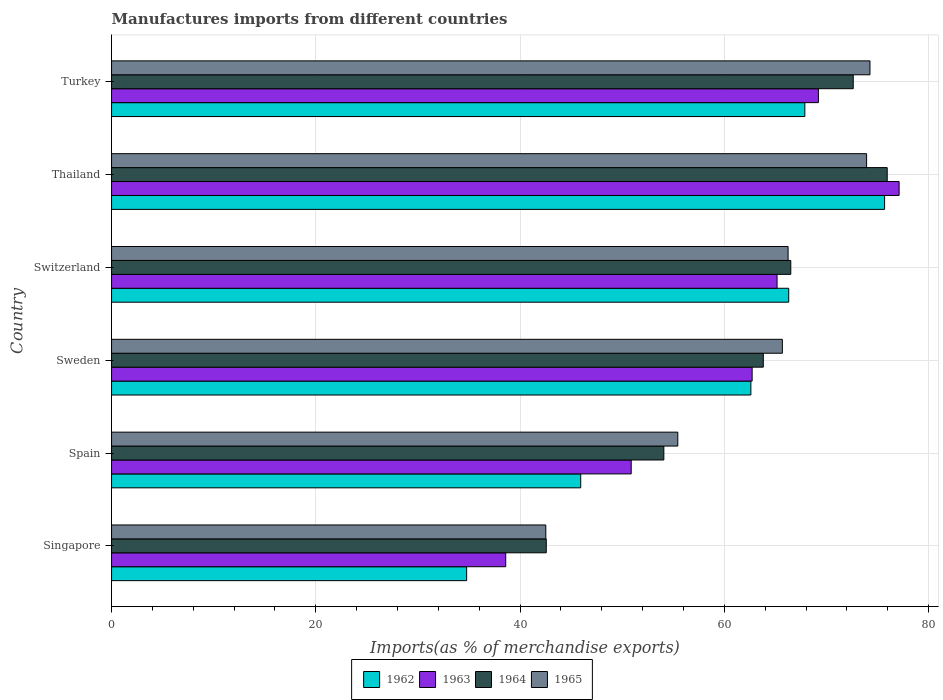How many different coloured bars are there?
Your answer should be compact. 4. Are the number of bars per tick equal to the number of legend labels?
Make the answer very short. Yes. Are the number of bars on each tick of the Y-axis equal?
Your answer should be very brief. Yes. How many bars are there on the 2nd tick from the top?
Your response must be concise. 4. How many bars are there on the 4th tick from the bottom?
Offer a very short reply. 4. What is the label of the 5th group of bars from the top?
Make the answer very short. Spain. In how many cases, is the number of bars for a given country not equal to the number of legend labels?
Ensure brevity in your answer.  0. What is the percentage of imports to different countries in 1965 in Thailand?
Your response must be concise. 73.93. Across all countries, what is the maximum percentage of imports to different countries in 1965?
Keep it short and to the point. 74.26. Across all countries, what is the minimum percentage of imports to different countries in 1964?
Ensure brevity in your answer.  42.56. In which country was the percentage of imports to different countries in 1965 maximum?
Offer a very short reply. Turkey. In which country was the percentage of imports to different countries in 1964 minimum?
Give a very brief answer. Singapore. What is the total percentage of imports to different countries in 1964 in the graph?
Give a very brief answer. 375.54. What is the difference between the percentage of imports to different countries in 1965 in Singapore and that in Switzerland?
Offer a very short reply. -23.72. What is the difference between the percentage of imports to different countries in 1965 in Turkey and the percentage of imports to different countries in 1964 in Singapore?
Your answer should be very brief. 31.7. What is the average percentage of imports to different countries in 1965 per country?
Provide a short and direct response. 63.01. What is the difference between the percentage of imports to different countries in 1964 and percentage of imports to different countries in 1963 in Sweden?
Offer a terse response. 1.09. What is the ratio of the percentage of imports to different countries in 1963 in Sweden to that in Turkey?
Offer a terse response. 0.91. Is the percentage of imports to different countries in 1964 in Sweden less than that in Switzerland?
Your answer should be compact. Yes. Is the difference between the percentage of imports to different countries in 1964 in Sweden and Turkey greater than the difference between the percentage of imports to different countries in 1963 in Sweden and Turkey?
Give a very brief answer. No. What is the difference between the highest and the second highest percentage of imports to different countries in 1963?
Offer a very short reply. 7.9. What is the difference between the highest and the lowest percentage of imports to different countries in 1963?
Keep it short and to the point. 38.52. In how many countries, is the percentage of imports to different countries in 1964 greater than the average percentage of imports to different countries in 1964 taken over all countries?
Offer a very short reply. 4. What does the 3rd bar from the top in Switzerland represents?
Your answer should be compact. 1963. Is it the case that in every country, the sum of the percentage of imports to different countries in 1964 and percentage of imports to different countries in 1963 is greater than the percentage of imports to different countries in 1965?
Provide a short and direct response. Yes. How many countries are there in the graph?
Your response must be concise. 6. Are the values on the major ticks of X-axis written in scientific E-notation?
Ensure brevity in your answer.  No. Does the graph contain any zero values?
Your answer should be compact. No. How many legend labels are there?
Offer a terse response. 4. How are the legend labels stacked?
Provide a short and direct response. Horizontal. What is the title of the graph?
Provide a short and direct response. Manufactures imports from different countries. Does "1968" appear as one of the legend labels in the graph?
Your answer should be compact. No. What is the label or title of the X-axis?
Ensure brevity in your answer.  Imports(as % of merchandise exports). What is the label or title of the Y-axis?
Your answer should be very brief. Country. What is the Imports(as % of merchandise exports) in 1962 in Singapore?
Your response must be concise. 34.77. What is the Imports(as % of merchandise exports) of 1963 in Singapore?
Keep it short and to the point. 38.6. What is the Imports(as % of merchandise exports) of 1964 in Singapore?
Your answer should be compact. 42.56. What is the Imports(as % of merchandise exports) in 1965 in Singapore?
Make the answer very short. 42.52. What is the Imports(as % of merchandise exports) in 1962 in Spain?
Offer a very short reply. 45.94. What is the Imports(as % of merchandise exports) of 1963 in Spain?
Offer a terse response. 50.88. What is the Imports(as % of merchandise exports) in 1964 in Spain?
Your answer should be compact. 54.08. What is the Imports(as % of merchandise exports) of 1965 in Spain?
Your answer should be compact. 55.44. What is the Imports(as % of merchandise exports) of 1962 in Sweden?
Your answer should be compact. 62.6. What is the Imports(as % of merchandise exports) in 1963 in Sweden?
Your response must be concise. 62.72. What is the Imports(as % of merchandise exports) in 1964 in Sweden?
Your response must be concise. 63.82. What is the Imports(as % of merchandise exports) of 1965 in Sweden?
Make the answer very short. 65.68. What is the Imports(as % of merchandise exports) of 1962 in Switzerland?
Your answer should be very brief. 66.31. What is the Imports(as % of merchandise exports) in 1963 in Switzerland?
Your answer should be compact. 65.16. What is the Imports(as % of merchandise exports) in 1964 in Switzerland?
Give a very brief answer. 66.51. What is the Imports(as % of merchandise exports) in 1965 in Switzerland?
Ensure brevity in your answer.  66.24. What is the Imports(as % of merchandise exports) of 1962 in Thailand?
Give a very brief answer. 75.69. What is the Imports(as % of merchandise exports) of 1963 in Thailand?
Your answer should be very brief. 77.12. What is the Imports(as % of merchandise exports) of 1964 in Thailand?
Give a very brief answer. 75.95. What is the Imports(as % of merchandise exports) in 1965 in Thailand?
Provide a short and direct response. 73.93. What is the Imports(as % of merchandise exports) in 1962 in Turkey?
Your response must be concise. 67.88. What is the Imports(as % of merchandise exports) in 1963 in Turkey?
Provide a short and direct response. 69.21. What is the Imports(as % of merchandise exports) of 1964 in Turkey?
Offer a terse response. 72.62. What is the Imports(as % of merchandise exports) in 1965 in Turkey?
Offer a terse response. 74.26. Across all countries, what is the maximum Imports(as % of merchandise exports) in 1962?
Provide a short and direct response. 75.69. Across all countries, what is the maximum Imports(as % of merchandise exports) in 1963?
Make the answer very short. 77.12. Across all countries, what is the maximum Imports(as % of merchandise exports) in 1964?
Give a very brief answer. 75.95. Across all countries, what is the maximum Imports(as % of merchandise exports) of 1965?
Provide a succinct answer. 74.26. Across all countries, what is the minimum Imports(as % of merchandise exports) of 1962?
Ensure brevity in your answer.  34.77. Across all countries, what is the minimum Imports(as % of merchandise exports) of 1963?
Provide a short and direct response. 38.6. Across all countries, what is the minimum Imports(as % of merchandise exports) of 1964?
Your answer should be compact. 42.56. Across all countries, what is the minimum Imports(as % of merchandise exports) in 1965?
Keep it short and to the point. 42.52. What is the total Imports(as % of merchandise exports) of 1962 in the graph?
Provide a succinct answer. 353.19. What is the total Imports(as % of merchandise exports) of 1963 in the graph?
Your response must be concise. 363.69. What is the total Imports(as % of merchandise exports) of 1964 in the graph?
Your answer should be compact. 375.54. What is the total Imports(as % of merchandise exports) of 1965 in the graph?
Give a very brief answer. 378.08. What is the difference between the Imports(as % of merchandise exports) of 1962 in Singapore and that in Spain?
Provide a succinct answer. -11.17. What is the difference between the Imports(as % of merchandise exports) in 1963 in Singapore and that in Spain?
Give a very brief answer. -12.29. What is the difference between the Imports(as % of merchandise exports) of 1964 in Singapore and that in Spain?
Your answer should be compact. -11.51. What is the difference between the Imports(as % of merchandise exports) in 1965 in Singapore and that in Spain?
Your answer should be compact. -12.92. What is the difference between the Imports(as % of merchandise exports) in 1962 in Singapore and that in Sweden?
Give a very brief answer. -27.83. What is the difference between the Imports(as % of merchandise exports) in 1963 in Singapore and that in Sweden?
Provide a short and direct response. -24.13. What is the difference between the Imports(as % of merchandise exports) in 1964 in Singapore and that in Sweden?
Ensure brevity in your answer.  -21.25. What is the difference between the Imports(as % of merchandise exports) in 1965 in Singapore and that in Sweden?
Offer a very short reply. -23.16. What is the difference between the Imports(as % of merchandise exports) in 1962 in Singapore and that in Switzerland?
Your response must be concise. -31.54. What is the difference between the Imports(as % of merchandise exports) in 1963 in Singapore and that in Switzerland?
Keep it short and to the point. -26.57. What is the difference between the Imports(as % of merchandise exports) of 1964 in Singapore and that in Switzerland?
Your response must be concise. -23.94. What is the difference between the Imports(as % of merchandise exports) of 1965 in Singapore and that in Switzerland?
Keep it short and to the point. -23.72. What is the difference between the Imports(as % of merchandise exports) in 1962 in Singapore and that in Thailand?
Ensure brevity in your answer.  -40.92. What is the difference between the Imports(as % of merchandise exports) of 1963 in Singapore and that in Thailand?
Offer a terse response. -38.52. What is the difference between the Imports(as % of merchandise exports) of 1964 in Singapore and that in Thailand?
Provide a succinct answer. -33.38. What is the difference between the Imports(as % of merchandise exports) of 1965 in Singapore and that in Thailand?
Your answer should be compact. -31.41. What is the difference between the Imports(as % of merchandise exports) in 1962 in Singapore and that in Turkey?
Keep it short and to the point. -33.11. What is the difference between the Imports(as % of merchandise exports) in 1963 in Singapore and that in Turkey?
Provide a short and direct response. -30.62. What is the difference between the Imports(as % of merchandise exports) in 1964 in Singapore and that in Turkey?
Ensure brevity in your answer.  -30.06. What is the difference between the Imports(as % of merchandise exports) of 1965 in Singapore and that in Turkey?
Make the answer very short. -31.74. What is the difference between the Imports(as % of merchandise exports) of 1962 in Spain and that in Sweden?
Provide a short and direct response. -16.66. What is the difference between the Imports(as % of merchandise exports) in 1963 in Spain and that in Sweden?
Your response must be concise. -11.84. What is the difference between the Imports(as % of merchandise exports) of 1964 in Spain and that in Sweden?
Your response must be concise. -9.74. What is the difference between the Imports(as % of merchandise exports) in 1965 in Spain and that in Sweden?
Make the answer very short. -10.24. What is the difference between the Imports(as % of merchandise exports) of 1962 in Spain and that in Switzerland?
Your answer should be very brief. -20.37. What is the difference between the Imports(as % of merchandise exports) in 1963 in Spain and that in Switzerland?
Your answer should be compact. -14.28. What is the difference between the Imports(as % of merchandise exports) of 1964 in Spain and that in Switzerland?
Offer a very short reply. -12.43. What is the difference between the Imports(as % of merchandise exports) in 1965 in Spain and that in Switzerland?
Offer a terse response. -10.8. What is the difference between the Imports(as % of merchandise exports) of 1962 in Spain and that in Thailand?
Your answer should be very brief. -29.75. What is the difference between the Imports(as % of merchandise exports) in 1963 in Spain and that in Thailand?
Offer a very short reply. -26.23. What is the difference between the Imports(as % of merchandise exports) in 1964 in Spain and that in Thailand?
Your response must be concise. -21.87. What is the difference between the Imports(as % of merchandise exports) of 1965 in Spain and that in Thailand?
Ensure brevity in your answer.  -18.49. What is the difference between the Imports(as % of merchandise exports) in 1962 in Spain and that in Turkey?
Give a very brief answer. -21.94. What is the difference between the Imports(as % of merchandise exports) in 1963 in Spain and that in Turkey?
Your response must be concise. -18.33. What is the difference between the Imports(as % of merchandise exports) of 1964 in Spain and that in Turkey?
Offer a terse response. -18.54. What is the difference between the Imports(as % of merchandise exports) in 1965 in Spain and that in Turkey?
Make the answer very short. -18.82. What is the difference between the Imports(as % of merchandise exports) of 1962 in Sweden and that in Switzerland?
Make the answer very short. -3.71. What is the difference between the Imports(as % of merchandise exports) in 1963 in Sweden and that in Switzerland?
Your response must be concise. -2.44. What is the difference between the Imports(as % of merchandise exports) in 1964 in Sweden and that in Switzerland?
Provide a succinct answer. -2.69. What is the difference between the Imports(as % of merchandise exports) of 1965 in Sweden and that in Switzerland?
Keep it short and to the point. -0.56. What is the difference between the Imports(as % of merchandise exports) in 1962 in Sweden and that in Thailand?
Your answer should be very brief. -13.09. What is the difference between the Imports(as % of merchandise exports) in 1963 in Sweden and that in Thailand?
Your answer should be very brief. -14.39. What is the difference between the Imports(as % of merchandise exports) of 1964 in Sweden and that in Thailand?
Your answer should be very brief. -12.13. What is the difference between the Imports(as % of merchandise exports) of 1965 in Sweden and that in Thailand?
Offer a very short reply. -8.25. What is the difference between the Imports(as % of merchandise exports) in 1962 in Sweden and that in Turkey?
Make the answer very short. -5.28. What is the difference between the Imports(as % of merchandise exports) in 1963 in Sweden and that in Turkey?
Offer a very short reply. -6.49. What is the difference between the Imports(as % of merchandise exports) of 1964 in Sweden and that in Turkey?
Make the answer very short. -8.81. What is the difference between the Imports(as % of merchandise exports) in 1965 in Sweden and that in Turkey?
Your response must be concise. -8.58. What is the difference between the Imports(as % of merchandise exports) in 1962 in Switzerland and that in Thailand?
Your response must be concise. -9.39. What is the difference between the Imports(as % of merchandise exports) in 1963 in Switzerland and that in Thailand?
Offer a terse response. -11.95. What is the difference between the Imports(as % of merchandise exports) of 1964 in Switzerland and that in Thailand?
Your answer should be compact. -9.44. What is the difference between the Imports(as % of merchandise exports) in 1965 in Switzerland and that in Thailand?
Provide a succinct answer. -7.69. What is the difference between the Imports(as % of merchandise exports) in 1962 in Switzerland and that in Turkey?
Your answer should be very brief. -1.58. What is the difference between the Imports(as % of merchandise exports) of 1963 in Switzerland and that in Turkey?
Your response must be concise. -4.05. What is the difference between the Imports(as % of merchandise exports) in 1964 in Switzerland and that in Turkey?
Your answer should be very brief. -6.12. What is the difference between the Imports(as % of merchandise exports) in 1965 in Switzerland and that in Turkey?
Your answer should be very brief. -8.02. What is the difference between the Imports(as % of merchandise exports) in 1962 in Thailand and that in Turkey?
Provide a succinct answer. 7.81. What is the difference between the Imports(as % of merchandise exports) of 1963 in Thailand and that in Turkey?
Your answer should be compact. 7.9. What is the difference between the Imports(as % of merchandise exports) in 1964 in Thailand and that in Turkey?
Give a very brief answer. 3.33. What is the difference between the Imports(as % of merchandise exports) of 1965 in Thailand and that in Turkey?
Your response must be concise. -0.33. What is the difference between the Imports(as % of merchandise exports) in 1962 in Singapore and the Imports(as % of merchandise exports) in 1963 in Spain?
Your response must be concise. -16.11. What is the difference between the Imports(as % of merchandise exports) of 1962 in Singapore and the Imports(as % of merchandise exports) of 1964 in Spain?
Offer a very short reply. -19.31. What is the difference between the Imports(as % of merchandise exports) of 1962 in Singapore and the Imports(as % of merchandise exports) of 1965 in Spain?
Your response must be concise. -20.68. What is the difference between the Imports(as % of merchandise exports) of 1963 in Singapore and the Imports(as % of merchandise exports) of 1964 in Spain?
Your response must be concise. -15.48. What is the difference between the Imports(as % of merchandise exports) of 1963 in Singapore and the Imports(as % of merchandise exports) of 1965 in Spain?
Ensure brevity in your answer.  -16.85. What is the difference between the Imports(as % of merchandise exports) in 1964 in Singapore and the Imports(as % of merchandise exports) in 1965 in Spain?
Provide a succinct answer. -12.88. What is the difference between the Imports(as % of merchandise exports) in 1962 in Singapore and the Imports(as % of merchandise exports) in 1963 in Sweden?
Give a very brief answer. -27.95. What is the difference between the Imports(as % of merchandise exports) in 1962 in Singapore and the Imports(as % of merchandise exports) in 1964 in Sweden?
Provide a succinct answer. -29.05. What is the difference between the Imports(as % of merchandise exports) in 1962 in Singapore and the Imports(as % of merchandise exports) in 1965 in Sweden?
Provide a succinct answer. -30.91. What is the difference between the Imports(as % of merchandise exports) in 1963 in Singapore and the Imports(as % of merchandise exports) in 1964 in Sweden?
Offer a terse response. -25.22. What is the difference between the Imports(as % of merchandise exports) in 1963 in Singapore and the Imports(as % of merchandise exports) in 1965 in Sweden?
Offer a very short reply. -27.09. What is the difference between the Imports(as % of merchandise exports) of 1964 in Singapore and the Imports(as % of merchandise exports) of 1965 in Sweden?
Your response must be concise. -23.12. What is the difference between the Imports(as % of merchandise exports) in 1962 in Singapore and the Imports(as % of merchandise exports) in 1963 in Switzerland?
Make the answer very short. -30.4. What is the difference between the Imports(as % of merchandise exports) in 1962 in Singapore and the Imports(as % of merchandise exports) in 1964 in Switzerland?
Make the answer very short. -31.74. What is the difference between the Imports(as % of merchandise exports) in 1962 in Singapore and the Imports(as % of merchandise exports) in 1965 in Switzerland?
Give a very brief answer. -31.48. What is the difference between the Imports(as % of merchandise exports) in 1963 in Singapore and the Imports(as % of merchandise exports) in 1964 in Switzerland?
Your answer should be compact. -27.91. What is the difference between the Imports(as % of merchandise exports) of 1963 in Singapore and the Imports(as % of merchandise exports) of 1965 in Switzerland?
Offer a very short reply. -27.65. What is the difference between the Imports(as % of merchandise exports) of 1964 in Singapore and the Imports(as % of merchandise exports) of 1965 in Switzerland?
Provide a short and direct response. -23.68. What is the difference between the Imports(as % of merchandise exports) of 1962 in Singapore and the Imports(as % of merchandise exports) of 1963 in Thailand?
Your answer should be very brief. -42.35. What is the difference between the Imports(as % of merchandise exports) in 1962 in Singapore and the Imports(as % of merchandise exports) in 1964 in Thailand?
Your answer should be very brief. -41.18. What is the difference between the Imports(as % of merchandise exports) of 1962 in Singapore and the Imports(as % of merchandise exports) of 1965 in Thailand?
Make the answer very short. -39.16. What is the difference between the Imports(as % of merchandise exports) of 1963 in Singapore and the Imports(as % of merchandise exports) of 1964 in Thailand?
Your response must be concise. -37.35. What is the difference between the Imports(as % of merchandise exports) of 1963 in Singapore and the Imports(as % of merchandise exports) of 1965 in Thailand?
Offer a very short reply. -35.34. What is the difference between the Imports(as % of merchandise exports) in 1964 in Singapore and the Imports(as % of merchandise exports) in 1965 in Thailand?
Make the answer very short. -31.37. What is the difference between the Imports(as % of merchandise exports) of 1962 in Singapore and the Imports(as % of merchandise exports) of 1963 in Turkey?
Your response must be concise. -34.44. What is the difference between the Imports(as % of merchandise exports) of 1962 in Singapore and the Imports(as % of merchandise exports) of 1964 in Turkey?
Offer a very short reply. -37.85. What is the difference between the Imports(as % of merchandise exports) of 1962 in Singapore and the Imports(as % of merchandise exports) of 1965 in Turkey?
Your response must be concise. -39.49. What is the difference between the Imports(as % of merchandise exports) in 1963 in Singapore and the Imports(as % of merchandise exports) in 1964 in Turkey?
Offer a very short reply. -34.03. What is the difference between the Imports(as % of merchandise exports) in 1963 in Singapore and the Imports(as % of merchandise exports) in 1965 in Turkey?
Make the answer very short. -35.67. What is the difference between the Imports(as % of merchandise exports) in 1964 in Singapore and the Imports(as % of merchandise exports) in 1965 in Turkey?
Provide a short and direct response. -31.7. What is the difference between the Imports(as % of merchandise exports) in 1962 in Spain and the Imports(as % of merchandise exports) in 1963 in Sweden?
Offer a very short reply. -16.78. What is the difference between the Imports(as % of merchandise exports) of 1962 in Spain and the Imports(as % of merchandise exports) of 1964 in Sweden?
Give a very brief answer. -17.88. What is the difference between the Imports(as % of merchandise exports) of 1962 in Spain and the Imports(as % of merchandise exports) of 1965 in Sweden?
Make the answer very short. -19.74. What is the difference between the Imports(as % of merchandise exports) in 1963 in Spain and the Imports(as % of merchandise exports) in 1964 in Sweden?
Give a very brief answer. -12.94. What is the difference between the Imports(as % of merchandise exports) in 1963 in Spain and the Imports(as % of merchandise exports) in 1965 in Sweden?
Make the answer very short. -14.8. What is the difference between the Imports(as % of merchandise exports) in 1964 in Spain and the Imports(as % of merchandise exports) in 1965 in Sweden?
Your answer should be compact. -11.6. What is the difference between the Imports(as % of merchandise exports) of 1962 in Spain and the Imports(as % of merchandise exports) of 1963 in Switzerland?
Make the answer very short. -19.23. What is the difference between the Imports(as % of merchandise exports) of 1962 in Spain and the Imports(as % of merchandise exports) of 1964 in Switzerland?
Make the answer very short. -20.57. What is the difference between the Imports(as % of merchandise exports) in 1962 in Spain and the Imports(as % of merchandise exports) in 1965 in Switzerland?
Offer a terse response. -20.31. What is the difference between the Imports(as % of merchandise exports) in 1963 in Spain and the Imports(as % of merchandise exports) in 1964 in Switzerland?
Offer a terse response. -15.63. What is the difference between the Imports(as % of merchandise exports) in 1963 in Spain and the Imports(as % of merchandise exports) in 1965 in Switzerland?
Keep it short and to the point. -15.36. What is the difference between the Imports(as % of merchandise exports) in 1964 in Spain and the Imports(as % of merchandise exports) in 1965 in Switzerland?
Offer a very short reply. -12.17. What is the difference between the Imports(as % of merchandise exports) in 1962 in Spain and the Imports(as % of merchandise exports) in 1963 in Thailand?
Make the answer very short. -31.18. What is the difference between the Imports(as % of merchandise exports) in 1962 in Spain and the Imports(as % of merchandise exports) in 1964 in Thailand?
Ensure brevity in your answer.  -30.01. What is the difference between the Imports(as % of merchandise exports) of 1962 in Spain and the Imports(as % of merchandise exports) of 1965 in Thailand?
Your response must be concise. -27.99. What is the difference between the Imports(as % of merchandise exports) in 1963 in Spain and the Imports(as % of merchandise exports) in 1964 in Thailand?
Offer a terse response. -25.07. What is the difference between the Imports(as % of merchandise exports) of 1963 in Spain and the Imports(as % of merchandise exports) of 1965 in Thailand?
Offer a very short reply. -23.05. What is the difference between the Imports(as % of merchandise exports) in 1964 in Spain and the Imports(as % of merchandise exports) in 1965 in Thailand?
Offer a terse response. -19.85. What is the difference between the Imports(as % of merchandise exports) of 1962 in Spain and the Imports(as % of merchandise exports) of 1963 in Turkey?
Provide a succinct answer. -23.27. What is the difference between the Imports(as % of merchandise exports) in 1962 in Spain and the Imports(as % of merchandise exports) in 1964 in Turkey?
Give a very brief answer. -26.68. What is the difference between the Imports(as % of merchandise exports) of 1962 in Spain and the Imports(as % of merchandise exports) of 1965 in Turkey?
Keep it short and to the point. -28.32. What is the difference between the Imports(as % of merchandise exports) of 1963 in Spain and the Imports(as % of merchandise exports) of 1964 in Turkey?
Your response must be concise. -21.74. What is the difference between the Imports(as % of merchandise exports) in 1963 in Spain and the Imports(as % of merchandise exports) in 1965 in Turkey?
Provide a short and direct response. -23.38. What is the difference between the Imports(as % of merchandise exports) of 1964 in Spain and the Imports(as % of merchandise exports) of 1965 in Turkey?
Make the answer very short. -20.18. What is the difference between the Imports(as % of merchandise exports) of 1962 in Sweden and the Imports(as % of merchandise exports) of 1963 in Switzerland?
Offer a very short reply. -2.57. What is the difference between the Imports(as % of merchandise exports) of 1962 in Sweden and the Imports(as % of merchandise exports) of 1964 in Switzerland?
Keep it short and to the point. -3.91. What is the difference between the Imports(as % of merchandise exports) of 1962 in Sweden and the Imports(as % of merchandise exports) of 1965 in Switzerland?
Give a very brief answer. -3.65. What is the difference between the Imports(as % of merchandise exports) in 1963 in Sweden and the Imports(as % of merchandise exports) in 1964 in Switzerland?
Offer a terse response. -3.78. What is the difference between the Imports(as % of merchandise exports) of 1963 in Sweden and the Imports(as % of merchandise exports) of 1965 in Switzerland?
Your answer should be very brief. -3.52. What is the difference between the Imports(as % of merchandise exports) in 1964 in Sweden and the Imports(as % of merchandise exports) in 1965 in Switzerland?
Your answer should be very brief. -2.43. What is the difference between the Imports(as % of merchandise exports) in 1962 in Sweden and the Imports(as % of merchandise exports) in 1963 in Thailand?
Offer a very short reply. -14.52. What is the difference between the Imports(as % of merchandise exports) of 1962 in Sweden and the Imports(as % of merchandise exports) of 1964 in Thailand?
Give a very brief answer. -13.35. What is the difference between the Imports(as % of merchandise exports) of 1962 in Sweden and the Imports(as % of merchandise exports) of 1965 in Thailand?
Your response must be concise. -11.33. What is the difference between the Imports(as % of merchandise exports) in 1963 in Sweden and the Imports(as % of merchandise exports) in 1964 in Thailand?
Make the answer very short. -13.23. What is the difference between the Imports(as % of merchandise exports) in 1963 in Sweden and the Imports(as % of merchandise exports) in 1965 in Thailand?
Give a very brief answer. -11.21. What is the difference between the Imports(as % of merchandise exports) of 1964 in Sweden and the Imports(as % of merchandise exports) of 1965 in Thailand?
Offer a very short reply. -10.11. What is the difference between the Imports(as % of merchandise exports) of 1962 in Sweden and the Imports(as % of merchandise exports) of 1963 in Turkey?
Your response must be concise. -6.61. What is the difference between the Imports(as % of merchandise exports) of 1962 in Sweden and the Imports(as % of merchandise exports) of 1964 in Turkey?
Make the answer very short. -10.02. What is the difference between the Imports(as % of merchandise exports) of 1962 in Sweden and the Imports(as % of merchandise exports) of 1965 in Turkey?
Provide a succinct answer. -11.66. What is the difference between the Imports(as % of merchandise exports) in 1963 in Sweden and the Imports(as % of merchandise exports) in 1964 in Turkey?
Offer a very short reply. -9.9. What is the difference between the Imports(as % of merchandise exports) of 1963 in Sweden and the Imports(as % of merchandise exports) of 1965 in Turkey?
Ensure brevity in your answer.  -11.54. What is the difference between the Imports(as % of merchandise exports) in 1964 in Sweden and the Imports(as % of merchandise exports) in 1965 in Turkey?
Keep it short and to the point. -10.44. What is the difference between the Imports(as % of merchandise exports) of 1962 in Switzerland and the Imports(as % of merchandise exports) of 1963 in Thailand?
Provide a succinct answer. -10.81. What is the difference between the Imports(as % of merchandise exports) in 1962 in Switzerland and the Imports(as % of merchandise exports) in 1964 in Thailand?
Your answer should be compact. -9.64. What is the difference between the Imports(as % of merchandise exports) of 1962 in Switzerland and the Imports(as % of merchandise exports) of 1965 in Thailand?
Make the answer very short. -7.63. What is the difference between the Imports(as % of merchandise exports) in 1963 in Switzerland and the Imports(as % of merchandise exports) in 1964 in Thailand?
Ensure brevity in your answer.  -10.78. What is the difference between the Imports(as % of merchandise exports) in 1963 in Switzerland and the Imports(as % of merchandise exports) in 1965 in Thailand?
Keep it short and to the point. -8.77. What is the difference between the Imports(as % of merchandise exports) in 1964 in Switzerland and the Imports(as % of merchandise exports) in 1965 in Thailand?
Offer a terse response. -7.42. What is the difference between the Imports(as % of merchandise exports) in 1962 in Switzerland and the Imports(as % of merchandise exports) in 1963 in Turkey?
Make the answer very short. -2.91. What is the difference between the Imports(as % of merchandise exports) of 1962 in Switzerland and the Imports(as % of merchandise exports) of 1964 in Turkey?
Give a very brief answer. -6.32. What is the difference between the Imports(as % of merchandise exports) in 1962 in Switzerland and the Imports(as % of merchandise exports) in 1965 in Turkey?
Your answer should be very brief. -7.96. What is the difference between the Imports(as % of merchandise exports) in 1963 in Switzerland and the Imports(as % of merchandise exports) in 1964 in Turkey?
Your response must be concise. -7.46. What is the difference between the Imports(as % of merchandise exports) in 1963 in Switzerland and the Imports(as % of merchandise exports) in 1965 in Turkey?
Offer a very short reply. -9.1. What is the difference between the Imports(as % of merchandise exports) of 1964 in Switzerland and the Imports(as % of merchandise exports) of 1965 in Turkey?
Offer a very short reply. -7.75. What is the difference between the Imports(as % of merchandise exports) in 1962 in Thailand and the Imports(as % of merchandise exports) in 1963 in Turkey?
Ensure brevity in your answer.  6.48. What is the difference between the Imports(as % of merchandise exports) of 1962 in Thailand and the Imports(as % of merchandise exports) of 1964 in Turkey?
Ensure brevity in your answer.  3.07. What is the difference between the Imports(as % of merchandise exports) of 1962 in Thailand and the Imports(as % of merchandise exports) of 1965 in Turkey?
Give a very brief answer. 1.43. What is the difference between the Imports(as % of merchandise exports) of 1963 in Thailand and the Imports(as % of merchandise exports) of 1964 in Turkey?
Keep it short and to the point. 4.49. What is the difference between the Imports(as % of merchandise exports) in 1963 in Thailand and the Imports(as % of merchandise exports) in 1965 in Turkey?
Offer a terse response. 2.85. What is the difference between the Imports(as % of merchandise exports) of 1964 in Thailand and the Imports(as % of merchandise exports) of 1965 in Turkey?
Make the answer very short. 1.69. What is the average Imports(as % of merchandise exports) of 1962 per country?
Offer a very short reply. 58.87. What is the average Imports(as % of merchandise exports) of 1963 per country?
Give a very brief answer. 60.62. What is the average Imports(as % of merchandise exports) in 1964 per country?
Provide a succinct answer. 62.59. What is the average Imports(as % of merchandise exports) in 1965 per country?
Offer a very short reply. 63.01. What is the difference between the Imports(as % of merchandise exports) of 1962 and Imports(as % of merchandise exports) of 1963 in Singapore?
Give a very brief answer. -3.83. What is the difference between the Imports(as % of merchandise exports) in 1962 and Imports(as % of merchandise exports) in 1964 in Singapore?
Provide a succinct answer. -7.8. What is the difference between the Imports(as % of merchandise exports) of 1962 and Imports(as % of merchandise exports) of 1965 in Singapore?
Provide a short and direct response. -7.75. What is the difference between the Imports(as % of merchandise exports) in 1963 and Imports(as % of merchandise exports) in 1964 in Singapore?
Make the answer very short. -3.97. What is the difference between the Imports(as % of merchandise exports) of 1963 and Imports(as % of merchandise exports) of 1965 in Singapore?
Give a very brief answer. -3.93. What is the difference between the Imports(as % of merchandise exports) in 1964 and Imports(as % of merchandise exports) in 1965 in Singapore?
Keep it short and to the point. 0.04. What is the difference between the Imports(as % of merchandise exports) of 1962 and Imports(as % of merchandise exports) of 1963 in Spain?
Provide a succinct answer. -4.94. What is the difference between the Imports(as % of merchandise exports) in 1962 and Imports(as % of merchandise exports) in 1964 in Spain?
Give a very brief answer. -8.14. What is the difference between the Imports(as % of merchandise exports) in 1962 and Imports(as % of merchandise exports) in 1965 in Spain?
Provide a succinct answer. -9.51. What is the difference between the Imports(as % of merchandise exports) of 1963 and Imports(as % of merchandise exports) of 1964 in Spain?
Offer a very short reply. -3.2. What is the difference between the Imports(as % of merchandise exports) of 1963 and Imports(as % of merchandise exports) of 1965 in Spain?
Ensure brevity in your answer.  -4.56. What is the difference between the Imports(as % of merchandise exports) in 1964 and Imports(as % of merchandise exports) in 1965 in Spain?
Offer a very short reply. -1.37. What is the difference between the Imports(as % of merchandise exports) in 1962 and Imports(as % of merchandise exports) in 1963 in Sweden?
Provide a short and direct response. -0.12. What is the difference between the Imports(as % of merchandise exports) of 1962 and Imports(as % of merchandise exports) of 1964 in Sweden?
Offer a terse response. -1.22. What is the difference between the Imports(as % of merchandise exports) of 1962 and Imports(as % of merchandise exports) of 1965 in Sweden?
Make the answer very short. -3.08. What is the difference between the Imports(as % of merchandise exports) of 1963 and Imports(as % of merchandise exports) of 1964 in Sweden?
Your answer should be compact. -1.09. What is the difference between the Imports(as % of merchandise exports) of 1963 and Imports(as % of merchandise exports) of 1965 in Sweden?
Give a very brief answer. -2.96. What is the difference between the Imports(as % of merchandise exports) of 1964 and Imports(as % of merchandise exports) of 1965 in Sweden?
Offer a terse response. -1.87. What is the difference between the Imports(as % of merchandise exports) in 1962 and Imports(as % of merchandise exports) in 1963 in Switzerland?
Your answer should be compact. 1.14. What is the difference between the Imports(as % of merchandise exports) in 1962 and Imports(as % of merchandise exports) in 1964 in Switzerland?
Provide a short and direct response. -0.2. What is the difference between the Imports(as % of merchandise exports) of 1962 and Imports(as % of merchandise exports) of 1965 in Switzerland?
Provide a short and direct response. 0.06. What is the difference between the Imports(as % of merchandise exports) of 1963 and Imports(as % of merchandise exports) of 1964 in Switzerland?
Offer a terse response. -1.34. What is the difference between the Imports(as % of merchandise exports) in 1963 and Imports(as % of merchandise exports) in 1965 in Switzerland?
Provide a short and direct response. -1.08. What is the difference between the Imports(as % of merchandise exports) of 1964 and Imports(as % of merchandise exports) of 1965 in Switzerland?
Give a very brief answer. 0.26. What is the difference between the Imports(as % of merchandise exports) of 1962 and Imports(as % of merchandise exports) of 1963 in Thailand?
Your answer should be compact. -1.42. What is the difference between the Imports(as % of merchandise exports) in 1962 and Imports(as % of merchandise exports) in 1964 in Thailand?
Keep it short and to the point. -0.26. What is the difference between the Imports(as % of merchandise exports) of 1962 and Imports(as % of merchandise exports) of 1965 in Thailand?
Provide a succinct answer. 1.76. What is the difference between the Imports(as % of merchandise exports) in 1963 and Imports(as % of merchandise exports) in 1964 in Thailand?
Offer a terse response. 1.17. What is the difference between the Imports(as % of merchandise exports) of 1963 and Imports(as % of merchandise exports) of 1965 in Thailand?
Keep it short and to the point. 3.18. What is the difference between the Imports(as % of merchandise exports) in 1964 and Imports(as % of merchandise exports) in 1965 in Thailand?
Ensure brevity in your answer.  2.02. What is the difference between the Imports(as % of merchandise exports) of 1962 and Imports(as % of merchandise exports) of 1963 in Turkey?
Offer a very short reply. -1.33. What is the difference between the Imports(as % of merchandise exports) in 1962 and Imports(as % of merchandise exports) in 1964 in Turkey?
Offer a terse response. -4.74. What is the difference between the Imports(as % of merchandise exports) in 1962 and Imports(as % of merchandise exports) in 1965 in Turkey?
Your answer should be very brief. -6.38. What is the difference between the Imports(as % of merchandise exports) in 1963 and Imports(as % of merchandise exports) in 1964 in Turkey?
Make the answer very short. -3.41. What is the difference between the Imports(as % of merchandise exports) in 1963 and Imports(as % of merchandise exports) in 1965 in Turkey?
Make the answer very short. -5.05. What is the difference between the Imports(as % of merchandise exports) in 1964 and Imports(as % of merchandise exports) in 1965 in Turkey?
Your answer should be compact. -1.64. What is the ratio of the Imports(as % of merchandise exports) in 1962 in Singapore to that in Spain?
Ensure brevity in your answer.  0.76. What is the ratio of the Imports(as % of merchandise exports) of 1963 in Singapore to that in Spain?
Your response must be concise. 0.76. What is the ratio of the Imports(as % of merchandise exports) in 1964 in Singapore to that in Spain?
Keep it short and to the point. 0.79. What is the ratio of the Imports(as % of merchandise exports) of 1965 in Singapore to that in Spain?
Keep it short and to the point. 0.77. What is the ratio of the Imports(as % of merchandise exports) of 1962 in Singapore to that in Sweden?
Ensure brevity in your answer.  0.56. What is the ratio of the Imports(as % of merchandise exports) of 1963 in Singapore to that in Sweden?
Give a very brief answer. 0.62. What is the ratio of the Imports(as % of merchandise exports) in 1964 in Singapore to that in Sweden?
Give a very brief answer. 0.67. What is the ratio of the Imports(as % of merchandise exports) in 1965 in Singapore to that in Sweden?
Offer a very short reply. 0.65. What is the ratio of the Imports(as % of merchandise exports) of 1962 in Singapore to that in Switzerland?
Provide a short and direct response. 0.52. What is the ratio of the Imports(as % of merchandise exports) in 1963 in Singapore to that in Switzerland?
Offer a terse response. 0.59. What is the ratio of the Imports(as % of merchandise exports) of 1964 in Singapore to that in Switzerland?
Keep it short and to the point. 0.64. What is the ratio of the Imports(as % of merchandise exports) in 1965 in Singapore to that in Switzerland?
Give a very brief answer. 0.64. What is the ratio of the Imports(as % of merchandise exports) in 1962 in Singapore to that in Thailand?
Offer a terse response. 0.46. What is the ratio of the Imports(as % of merchandise exports) of 1963 in Singapore to that in Thailand?
Your answer should be compact. 0.5. What is the ratio of the Imports(as % of merchandise exports) in 1964 in Singapore to that in Thailand?
Provide a succinct answer. 0.56. What is the ratio of the Imports(as % of merchandise exports) of 1965 in Singapore to that in Thailand?
Provide a short and direct response. 0.58. What is the ratio of the Imports(as % of merchandise exports) in 1962 in Singapore to that in Turkey?
Offer a terse response. 0.51. What is the ratio of the Imports(as % of merchandise exports) of 1963 in Singapore to that in Turkey?
Keep it short and to the point. 0.56. What is the ratio of the Imports(as % of merchandise exports) in 1964 in Singapore to that in Turkey?
Offer a terse response. 0.59. What is the ratio of the Imports(as % of merchandise exports) in 1965 in Singapore to that in Turkey?
Your answer should be very brief. 0.57. What is the ratio of the Imports(as % of merchandise exports) of 1962 in Spain to that in Sweden?
Make the answer very short. 0.73. What is the ratio of the Imports(as % of merchandise exports) in 1963 in Spain to that in Sweden?
Offer a terse response. 0.81. What is the ratio of the Imports(as % of merchandise exports) of 1964 in Spain to that in Sweden?
Provide a short and direct response. 0.85. What is the ratio of the Imports(as % of merchandise exports) of 1965 in Spain to that in Sweden?
Offer a terse response. 0.84. What is the ratio of the Imports(as % of merchandise exports) of 1962 in Spain to that in Switzerland?
Your response must be concise. 0.69. What is the ratio of the Imports(as % of merchandise exports) of 1963 in Spain to that in Switzerland?
Offer a terse response. 0.78. What is the ratio of the Imports(as % of merchandise exports) of 1964 in Spain to that in Switzerland?
Provide a short and direct response. 0.81. What is the ratio of the Imports(as % of merchandise exports) in 1965 in Spain to that in Switzerland?
Keep it short and to the point. 0.84. What is the ratio of the Imports(as % of merchandise exports) of 1962 in Spain to that in Thailand?
Provide a short and direct response. 0.61. What is the ratio of the Imports(as % of merchandise exports) in 1963 in Spain to that in Thailand?
Make the answer very short. 0.66. What is the ratio of the Imports(as % of merchandise exports) in 1964 in Spain to that in Thailand?
Give a very brief answer. 0.71. What is the ratio of the Imports(as % of merchandise exports) of 1962 in Spain to that in Turkey?
Make the answer very short. 0.68. What is the ratio of the Imports(as % of merchandise exports) of 1963 in Spain to that in Turkey?
Ensure brevity in your answer.  0.74. What is the ratio of the Imports(as % of merchandise exports) in 1964 in Spain to that in Turkey?
Ensure brevity in your answer.  0.74. What is the ratio of the Imports(as % of merchandise exports) of 1965 in Spain to that in Turkey?
Make the answer very short. 0.75. What is the ratio of the Imports(as % of merchandise exports) of 1962 in Sweden to that in Switzerland?
Provide a short and direct response. 0.94. What is the ratio of the Imports(as % of merchandise exports) in 1963 in Sweden to that in Switzerland?
Your response must be concise. 0.96. What is the ratio of the Imports(as % of merchandise exports) in 1964 in Sweden to that in Switzerland?
Offer a very short reply. 0.96. What is the ratio of the Imports(as % of merchandise exports) in 1962 in Sweden to that in Thailand?
Your answer should be very brief. 0.83. What is the ratio of the Imports(as % of merchandise exports) of 1963 in Sweden to that in Thailand?
Provide a succinct answer. 0.81. What is the ratio of the Imports(as % of merchandise exports) in 1964 in Sweden to that in Thailand?
Offer a terse response. 0.84. What is the ratio of the Imports(as % of merchandise exports) of 1965 in Sweden to that in Thailand?
Your answer should be compact. 0.89. What is the ratio of the Imports(as % of merchandise exports) in 1962 in Sweden to that in Turkey?
Give a very brief answer. 0.92. What is the ratio of the Imports(as % of merchandise exports) of 1963 in Sweden to that in Turkey?
Provide a short and direct response. 0.91. What is the ratio of the Imports(as % of merchandise exports) of 1964 in Sweden to that in Turkey?
Offer a very short reply. 0.88. What is the ratio of the Imports(as % of merchandise exports) in 1965 in Sweden to that in Turkey?
Offer a very short reply. 0.88. What is the ratio of the Imports(as % of merchandise exports) in 1962 in Switzerland to that in Thailand?
Keep it short and to the point. 0.88. What is the ratio of the Imports(as % of merchandise exports) in 1963 in Switzerland to that in Thailand?
Your answer should be very brief. 0.84. What is the ratio of the Imports(as % of merchandise exports) of 1964 in Switzerland to that in Thailand?
Keep it short and to the point. 0.88. What is the ratio of the Imports(as % of merchandise exports) in 1965 in Switzerland to that in Thailand?
Provide a succinct answer. 0.9. What is the ratio of the Imports(as % of merchandise exports) of 1962 in Switzerland to that in Turkey?
Your answer should be compact. 0.98. What is the ratio of the Imports(as % of merchandise exports) of 1963 in Switzerland to that in Turkey?
Give a very brief answer. 0.94. What is the ratio of the Imports(as % of merchandise exports) in 1964 in Switzerland to that in Turkey?
Your answer should be compact. 0.92. What is the ratio of the Imports(as % of merchandise exports) of 1965 in Switzerland to that in Turkey?
Your answer should be compact. 0.89. What is the ratio of the Imports(as % of merchandise exports) in 1962 in Thailand to that in Turkey?
Your answer should be very brief. 1.11. What is the ratio of the Imports(as % of merchandise exports) of 1963 in Thailand to that in Turkey?
Your answer should be very brief. 1.11. What is the ratio of the Imports(as % of merchandise exports) of 1964 in Thailand to that in Turkey?
Your response must be concise. 1.05. What is the difference between the highest and the second highest Imports(as % of merchandise exports) of 1962?
Your response must be concise. 7.81. What is the difference between the highest and the second highest Imports(as % of merchandise exports) in 1963?
Provide a succinct answer. 7.9. What is the difference between the highest and the second highest Imports(as % of merchandise exports) in 1964?
Keep it short and to the point. 3.33. What is the difference between the highest and the second highest Imports(as % of merchandise exports) in 1965?
Offer a terse response. 0.33. What is the difference between the highest and the lowest Imports(as % of merchandise exports) in 1962?
Your answer should be very brief. 40.92. What is the difference between the highest and the lowest Imports(as % of merchandise exports) in 1963?
Your response must be concise. 38.52. What is the difference between the highest and the lowest Imports(as % of merchandise exports) in 1964?
Give a very brief answer. 33.38. What is the difference between the highest and the lowest Imports(as % of merchandise exports) in 1965?
Make the answer very short. 31.74. 